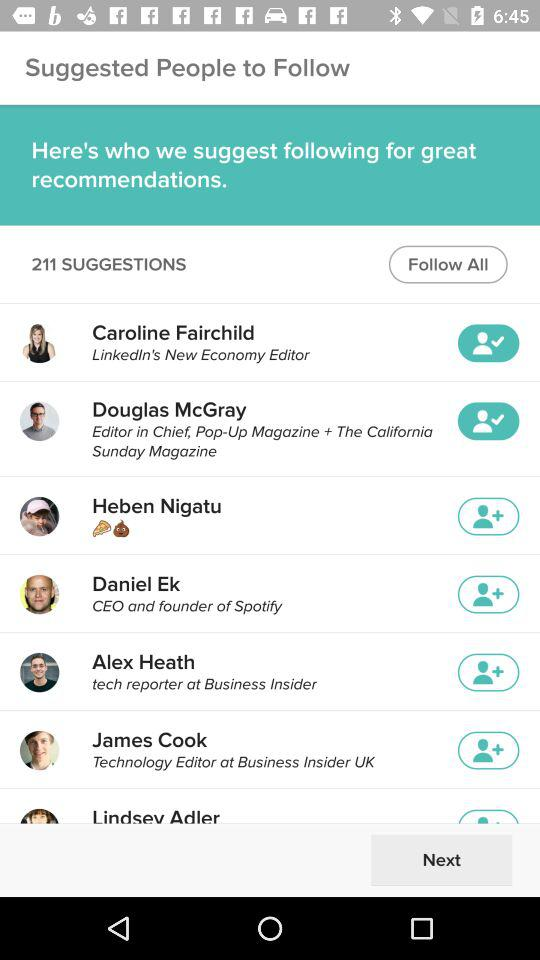Who is LinkedIn's new economy editor? LinkedIn's new economy editor is Caroline Fairchild. 